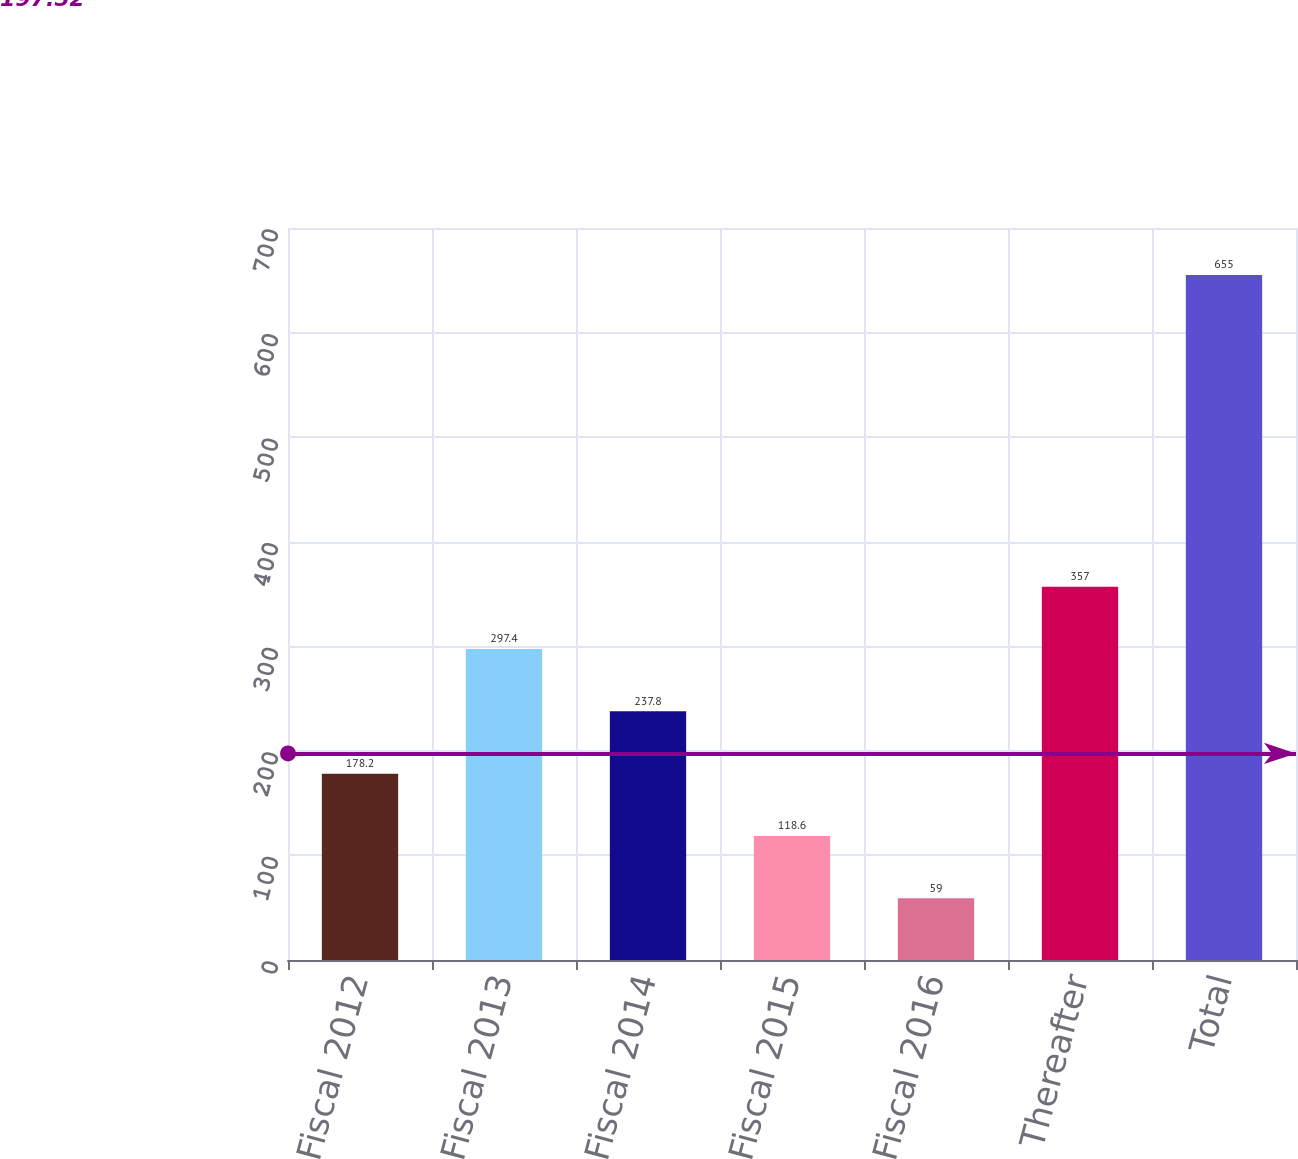Convert chart to OTSL. <chart><loc_0><loc_0><loc_500><loc_500><bar_chart><fcel>Fiscal 2012<fcel>Fiscal 2013<fcel>Fiscal 2014<fcel>Fiscal 2015<fcel>Fiscal 2016<fcel>Thereafter<fcel>Total<nl><fcel>178.2<fcel>297.4<fcel>237.8<fcel>118.6<fcel>59<fcel>357<fcel>655<nl></chart> 